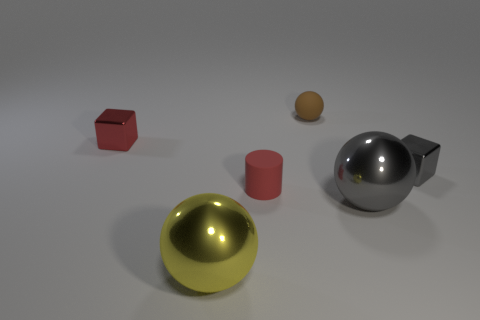Add 2 rubber objects. How many objects exist? 8 Subtract all cubes. How many objects are left? 4 Add 5 spheres. How many spheres are left? 8 Add 6 cylinders. How many cylinders exist? 7 Subtract 0 purple cubes. How many objects are left? 6 Subtract all small gray metallic objects. Subtract all red shiny things. How many objects are left? 4 